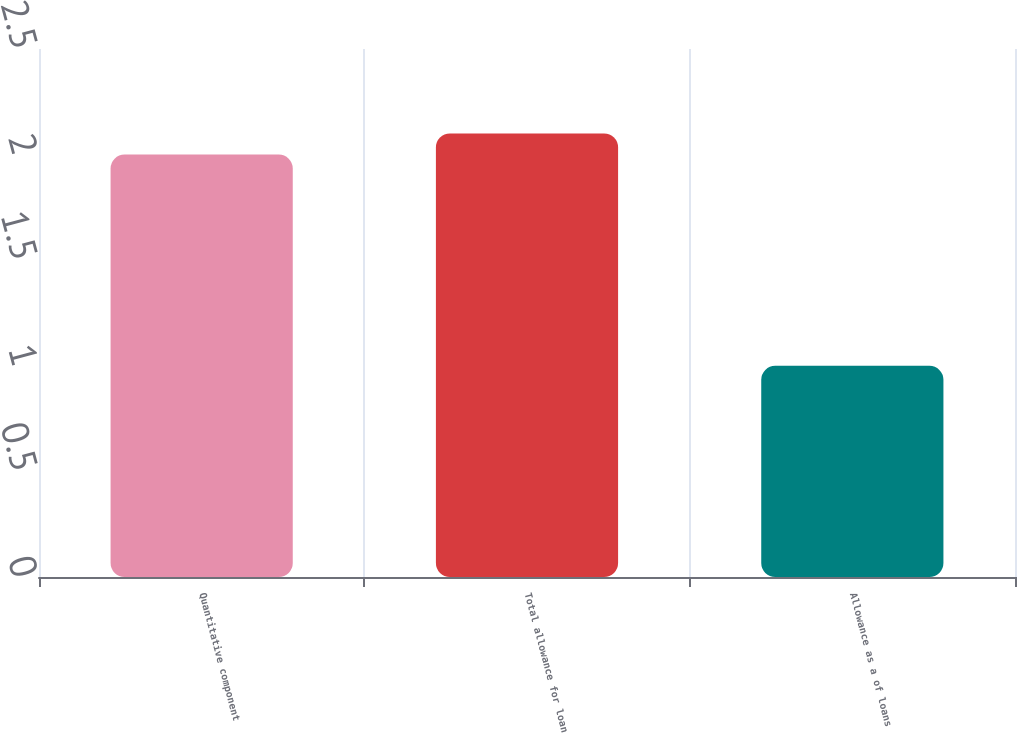Convert chart to OTSL. <chart><loc_0><loc_0><loc_500><loc_500><bar_chart><fcel>Quantitative component<fcel>Total allowance for loan<fcel>Allowance as a of loans<nl><fcel>2<fcel>2.1<fcel>1<nl></chart> 